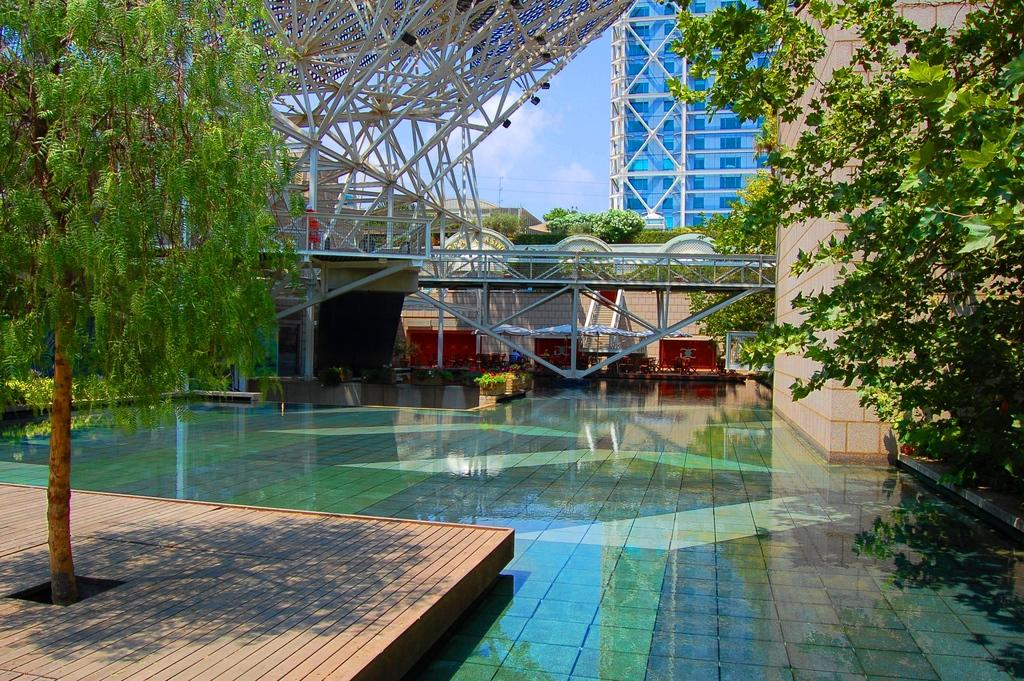What type of structure can be seen in the background of the image? There is a building in the background of the image. What natural elements are present in the image? There are trees in the image. What can be seen at the bottom of the image? There is water visible at the bottom of the image. What type of celery is being offered by the stranger in the image? There is no celery or stranger present in the image. How does the image depict the act of saying good-bye? The image does not depict any act of saying good-bye. 